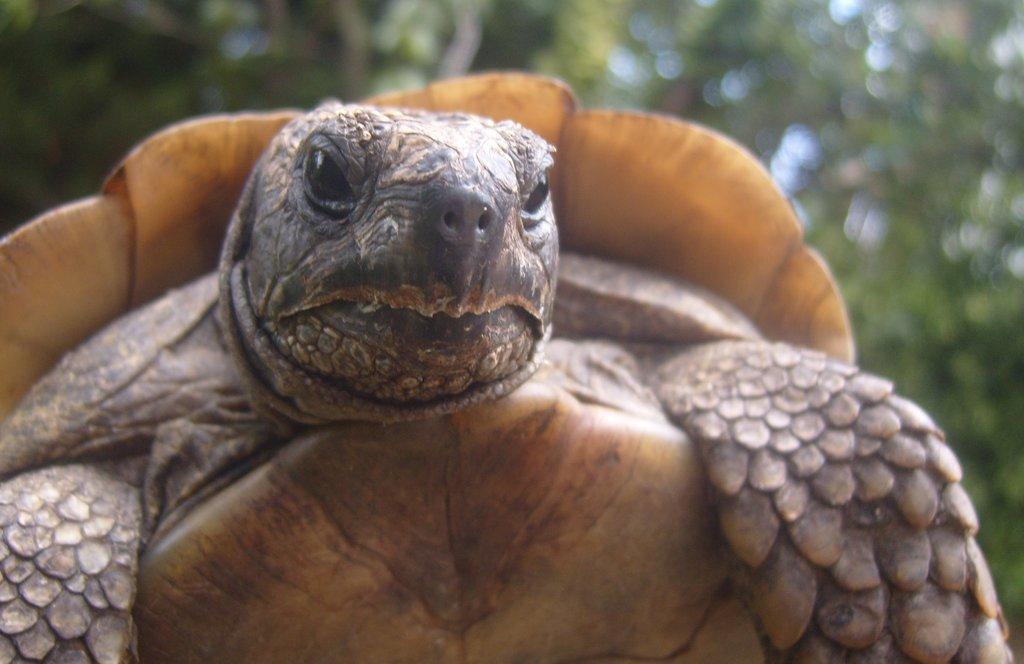Can you describe this image briefly? In this image in the foreground there is one turtle, and in the background there are some trees. 